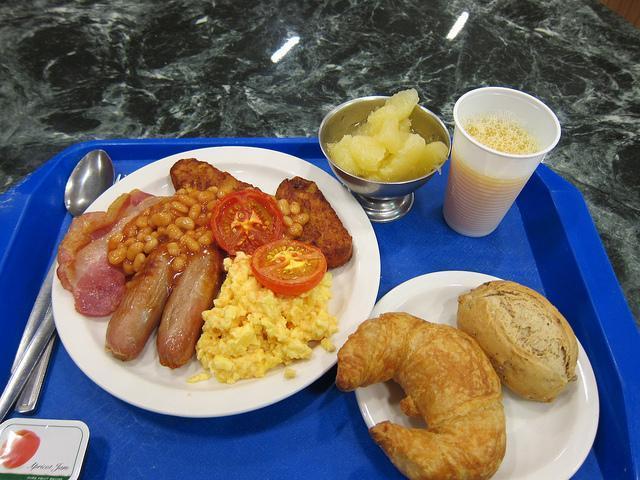How many hot dogs are there?
Give a very brief answer. 2. 